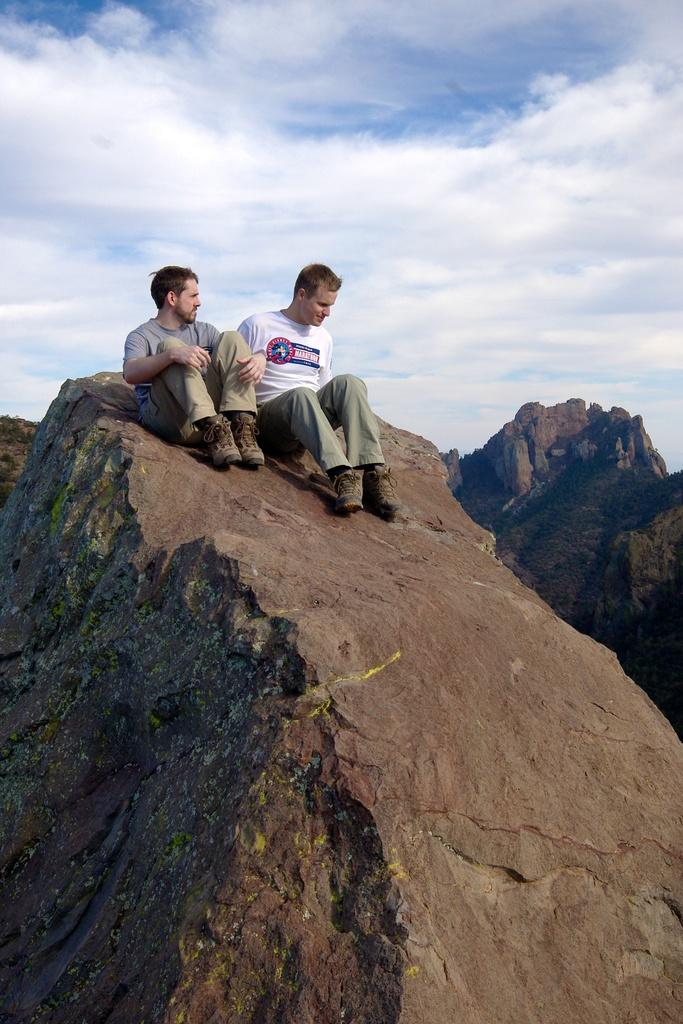How many people are in the image? There are two men in the image. What are the men doing in the image? The men are sitting on a rock. What can be seen in the background of the image? There are hills in the background of the image. What is visible at the top of the image? The sky is visible at the top of the image. What is the condition of the sky in the image? Clouds are present in the sky. What type of drum can be heard playing in the background of the image? There is no drum or sound present in the image; it is a still photograph. 